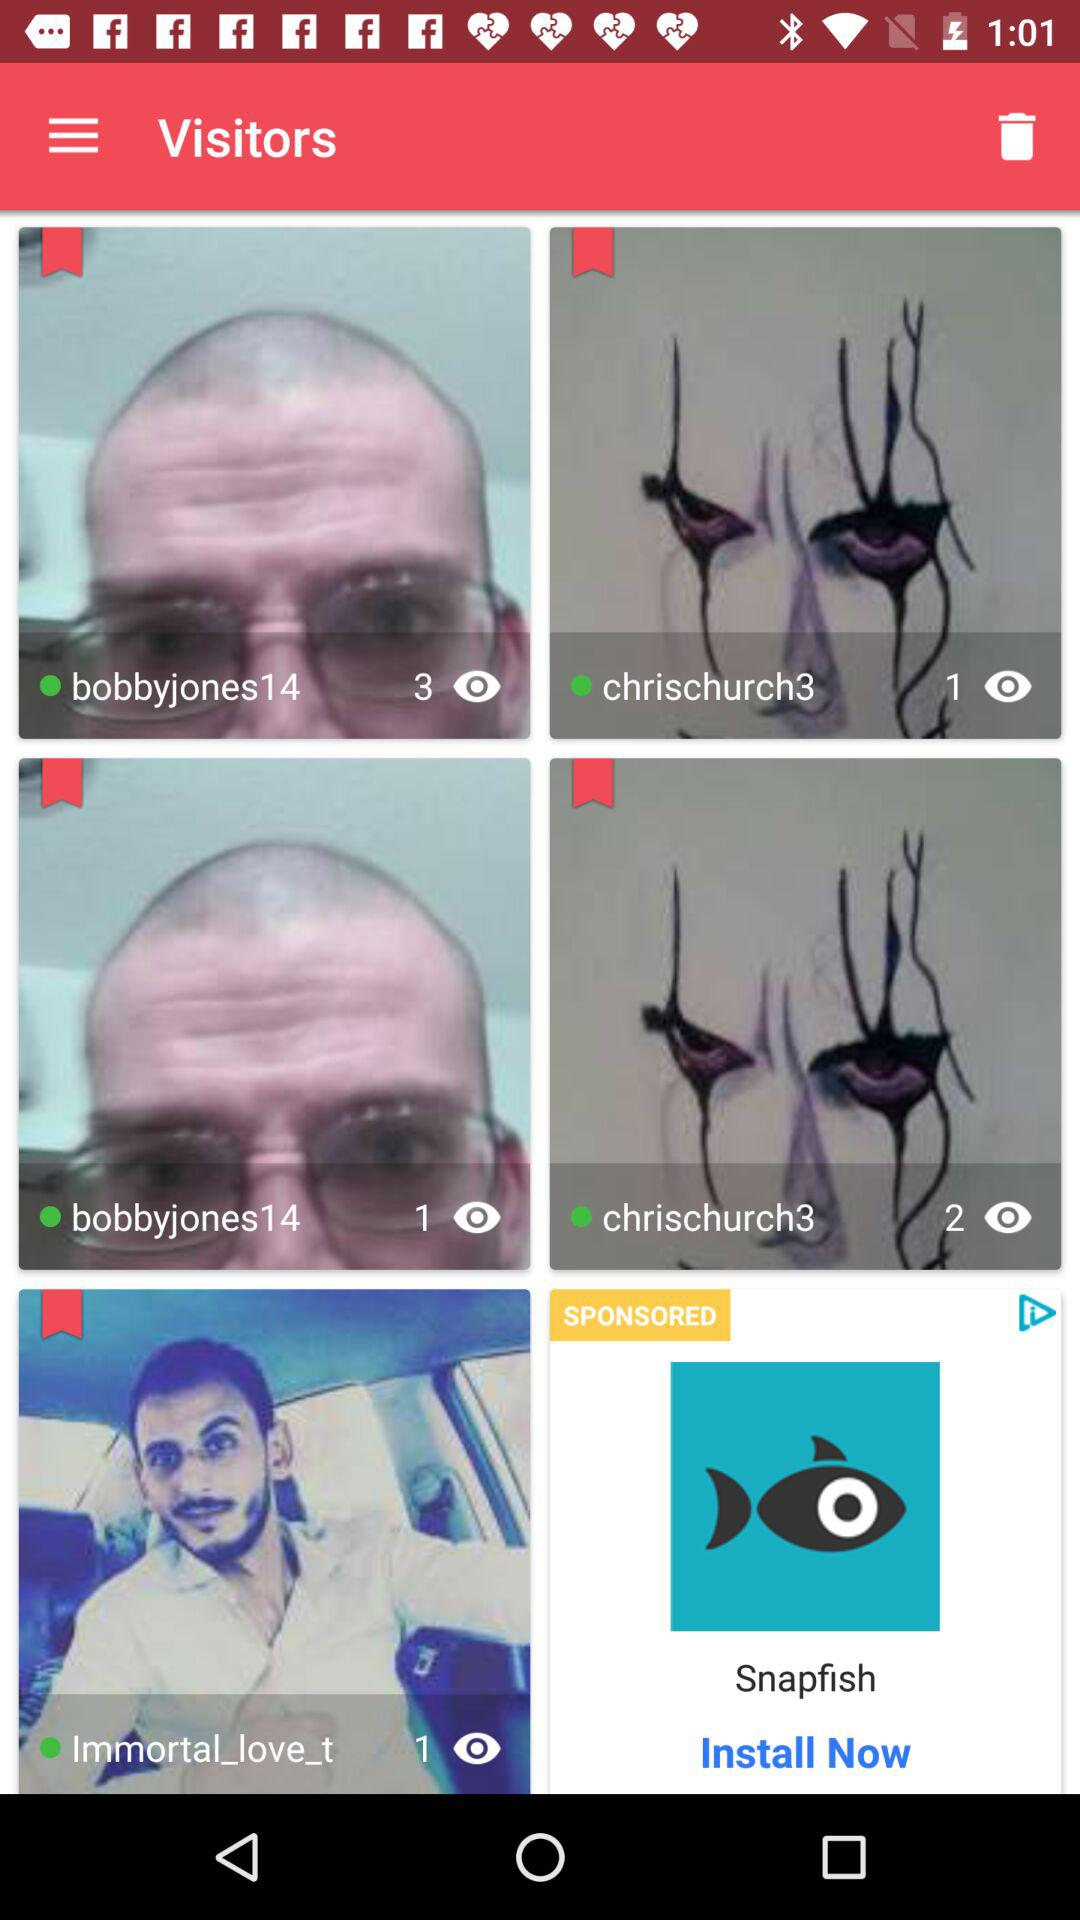How many more visitors have visited the profile of bobbyjones14 than chrischurch3?
Answer the question using a single word or phrase. 2 